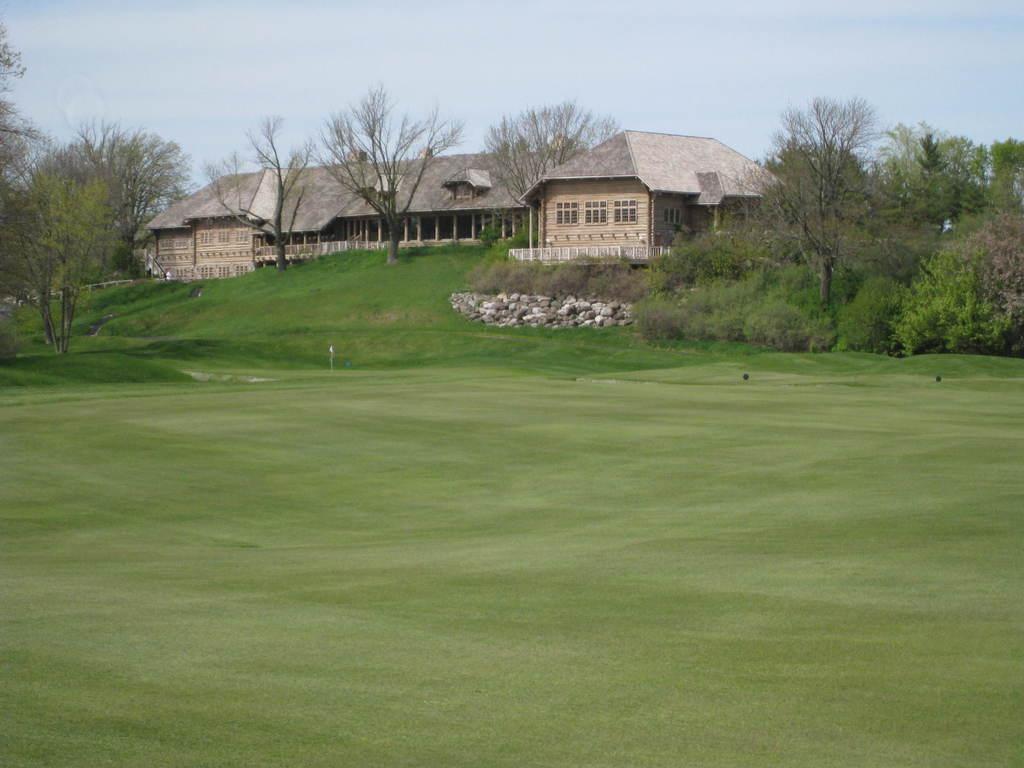Describe this image in one or two sentences. In this image I can see few houses,windows,trees,few rocks. The sky is in blue and white color. 